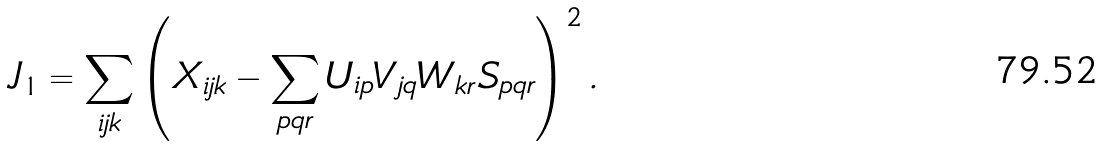<formula> <loc_0><loc_0><loc_500><loc_500>J _ { 1 } = \sum _ { i j k } \left ( X _ { i j k } - \sum _ { p q r } U _ { i p } V _ { j q } W _ { k r } S _ { p q r } \right ) ^ { 2 } .</formula> 